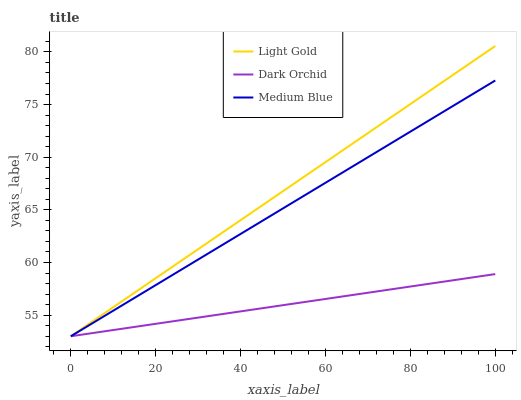Does Dark Orchid have the minimum area under the curve?
Answer yes or no. Yes. Does Light Gold have the maximum area under the curve?
Answer yes or no. Yes. Does Light Gold have the minimum area under the curve?
Answer yes or no. No. Does Dark Orchid have the maximum area under the curve?
Answer yes or no. No. Is Light Gold the smoothest?
Answer yes or no. Yes. Is Medium Blue the roughest?
Answer yes or no. Yes. Is Dark Orchid the smoothest?
Answer yes or no. No. Is Dark Orchid the roughest?
Answer yes or no. No. Does Medium Blue have the lowest value?
Answer yes or no. Yes. Does Light Gold have the highest value?
Answer yes or no. Yes. Does Dark Orchid have the highest value?
Answer yes or no. No. Does Medium Blue intersect Light Gold?
Answer yes or no. Yes. Is Medium Blue less than Light Gold?
Answer yes or no. No. Is Medium Blue greater than Light Gold?
Answer yes or no. No. 